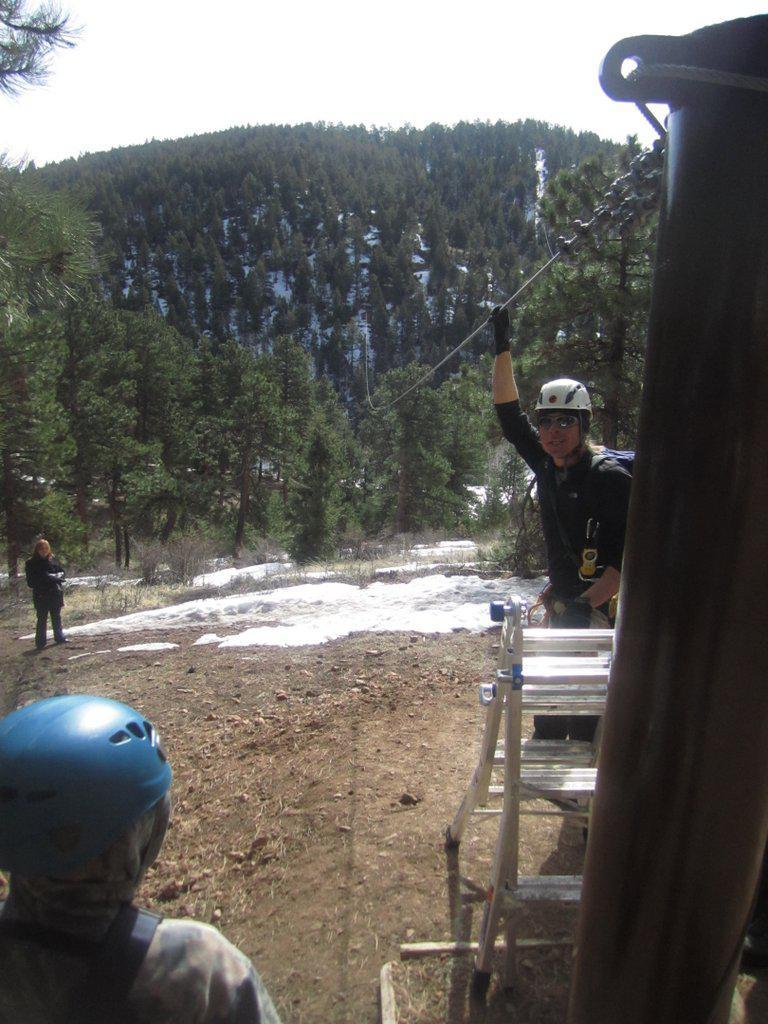What are the people in the image doing? The persons standing on the ground in the image are likely engaged in some activity or task. What objects can be seen in the image that might be used for climbing or reaching higher places? There is a ladder and a pole in the image that could be used for climbing or reaching higher places. What other objects can be seen in the image? There is a chain and cables in the image. What type of natural environment is visible in the image? There are trees in the image, indicating a natural environment. What is visible in the background of the image? The sky is visible in the image, providing context for the time of day or weather conditions. What type of thunder can be heard in the image? There is no sound present in the image, so it is not possible to determine if thunder can be heard. 